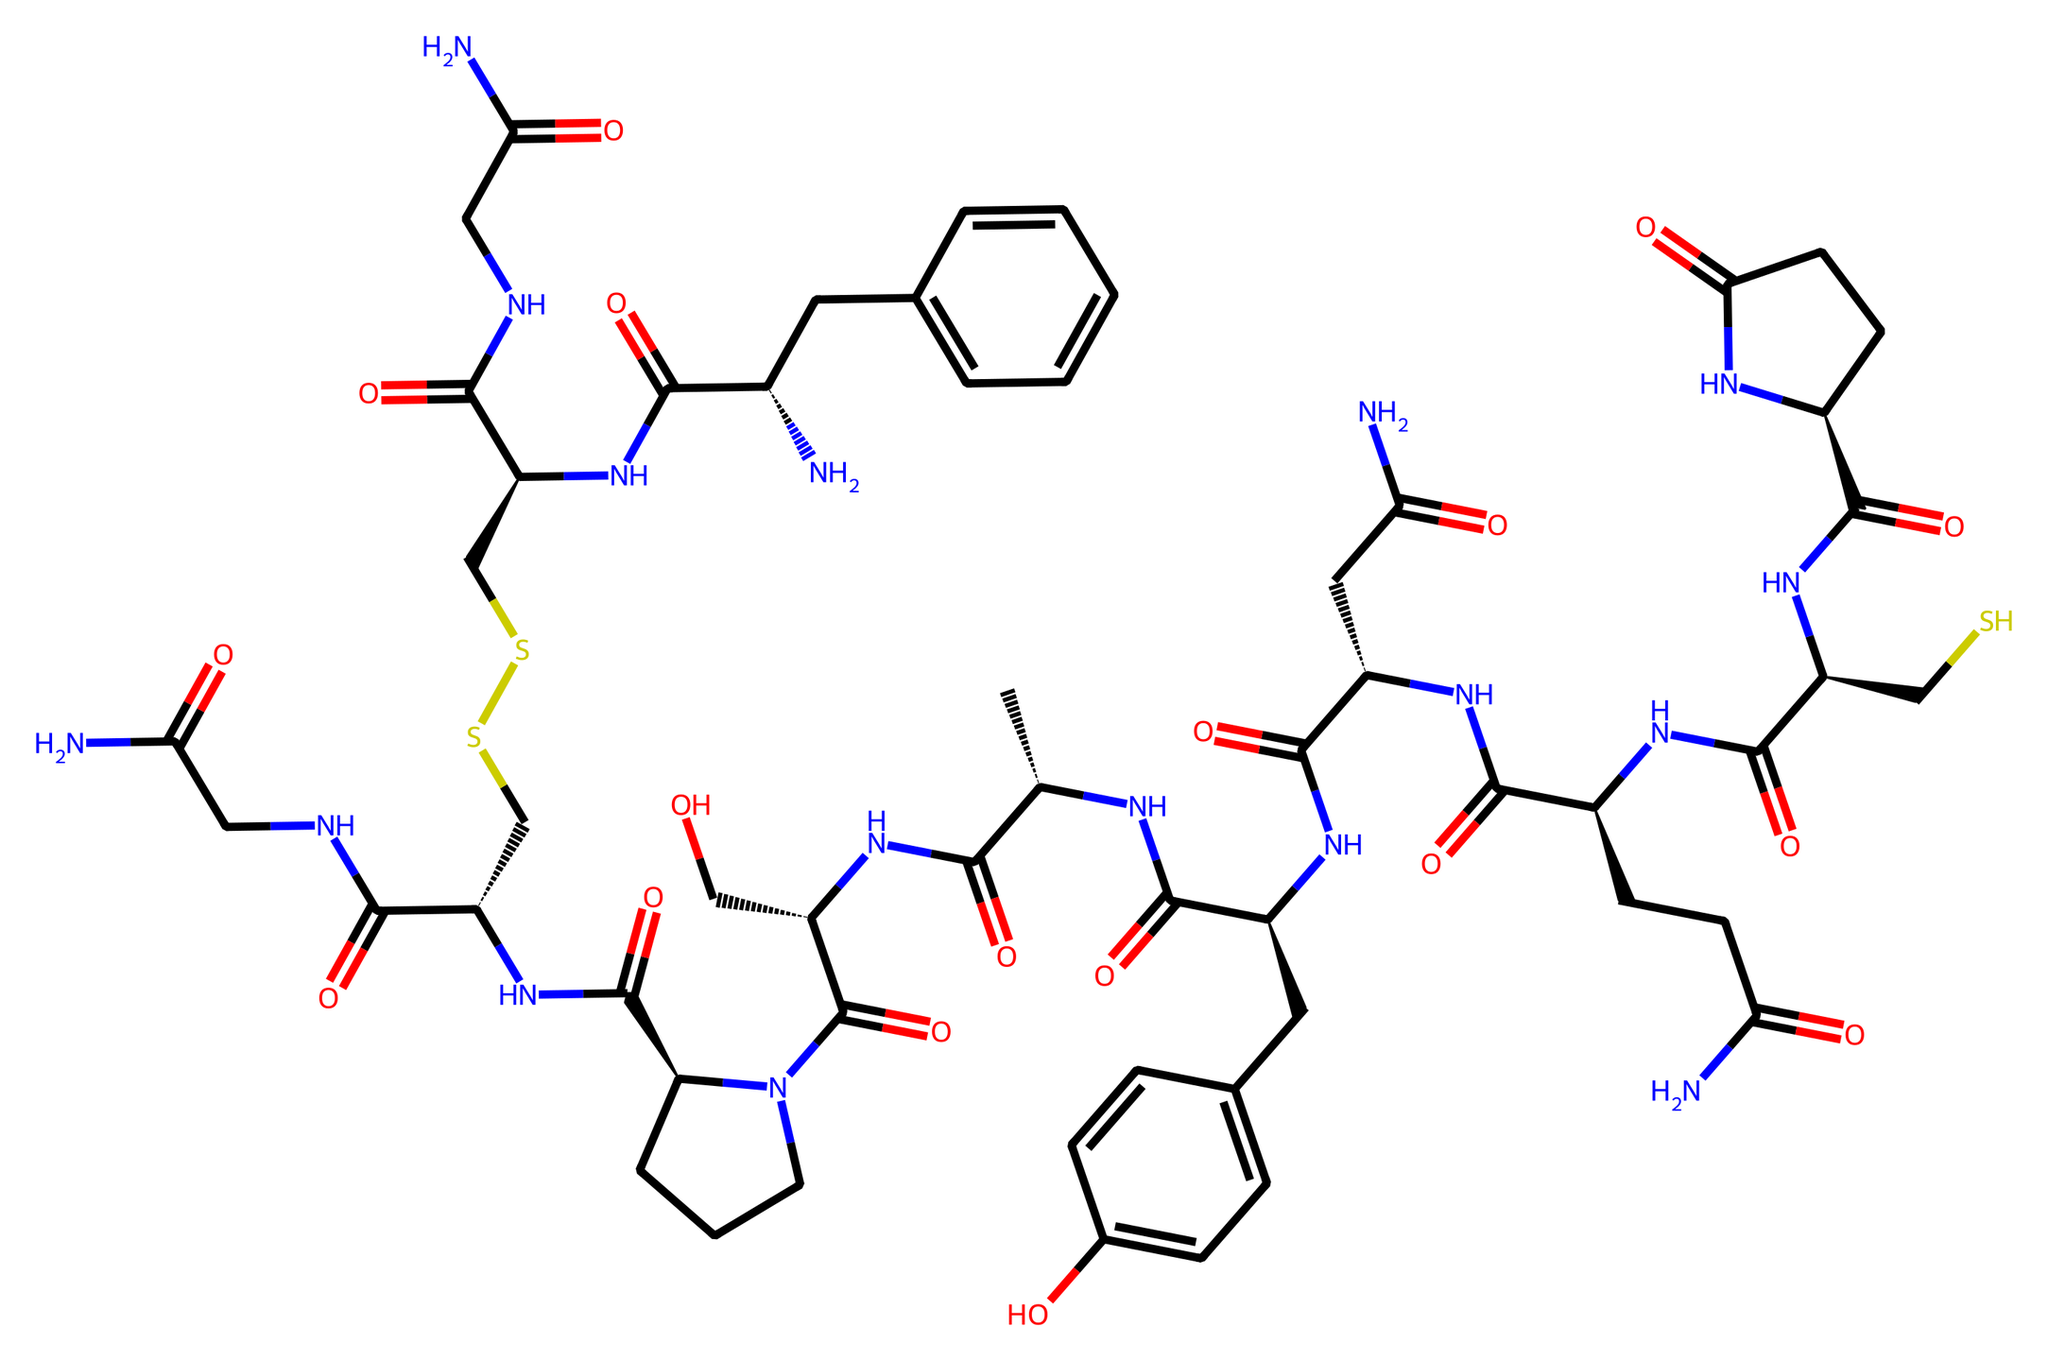What is the name of the chemical represented by this SMILES? The SMILES represents a complex structure associated with oxytocin, a peptide hormone involved in social bonding and emotional regulation.
Answer: oxytocin How many carbon atoms are present in this chemical? By inspecting the SMILES representation closely, we can count a total of 27 carbon atoms.
Answer: 27 How many nitrogen atoms are in this molecule? The SMILES structure reveals that there are 13 nitrogen atoms in total, which are indicated by the presence of N symbols throughout the arrangement.
Answer: 13 Does this chemical have any aromatic rings? The structure displays at least one aromatic ring, particularly the phenolic component represented by the cyclic carbon arrangement with alternating double bonds (the benzene ring).
Answer: yes Which functional groups are prevalent in this molecule? Analyzing the SMILES reveals multiple amide (–C(=O)N–) and hydroxyl (–OH) functional groups as key features within the oxytocin structure, contributing to its biological function.
Answer: amide, hydroxyl What type of molecular structure does oxytocin represent? This SMILES indicates that oxytocin is a peptide, which refers to the presence of linked amino acids forming a chain and thus categorizing it as a polypeptide or protein.
Answer: peptide Is there a disulfide bond present in this molecule? A disulfide bond is typically represented by a “S-S” structure in the SMILES, and in this case, the presence of “CSSC” indicates a disulfide bond is indeed present in oxytocin.
Answer: yes 